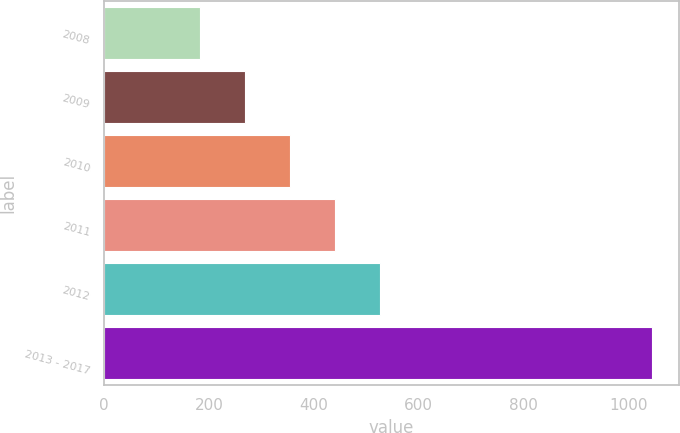Convert chart. <chart><loc_0><loc_0><loc_500><loc_500><bar_chart><fcel>2008<fcel>2009<fcel>2010<fcel>2011<fcel>2012<fcel>2013 - 2017<nl><fcel>182<fcel>268.2<fcel>354.4<fcel>440.6<fcel>526.8<fcel>1044<nl></chart> 